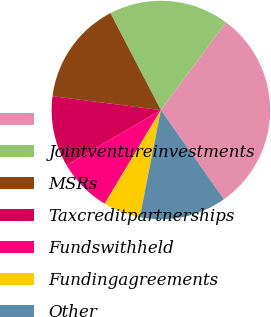<chart> <loc_0><loc_0><loc_500><loc_500><pie_chart><ecel><fcel>Jointventureinvestments<fcel>MSRs<fcel>Taxcreditpartnerships<fcel>Fundswithheld<fcel>Fundingagreements<fcel>Other<nl><fcel>30.06%<fcel>17.79%<fcel>15.34%<fcel>10.43%<fcel>7.98%<fcel>5.52%<fcel>12.88%<nl></chart> 